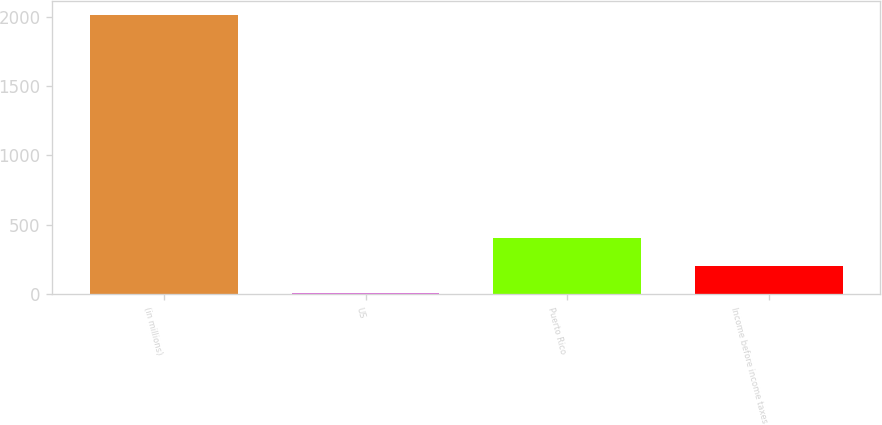Convert chart. <chart><loc_0><loc_0><loc_500><loc_500><bar_chart><fcel>(in millions)<fcel>US<fcel>Puerto Rico<fcel>Income before income taxes<nl><fcel>2013<fcel>5<fcel>406.6<fcel>205.8<nl></chart> 